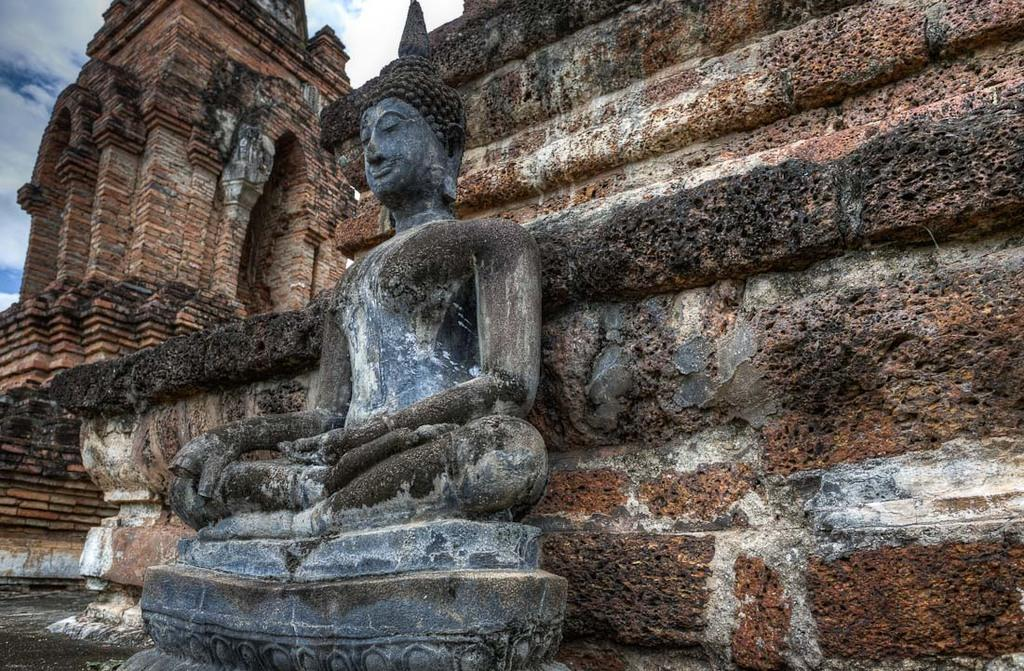What type of building is in the image? There is a temple in the image. What can be seen in front of the temple's wall? There is a sculpture of a god in front of the temple's wall. Can you tell me how many goldfish are swimming in the temple's fountain? There is no fountain or goldfish present in the image; it features a temple and a sculpture of a god. 